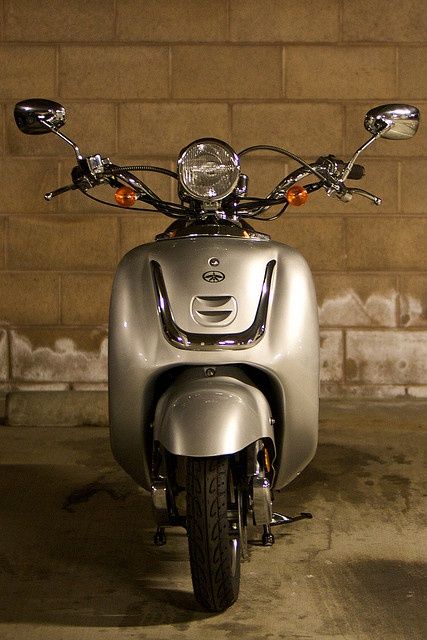Describe the objects in this image and their specific colors. I can see a motorcycle in maroon, black, gray, and tan tones in this image. 